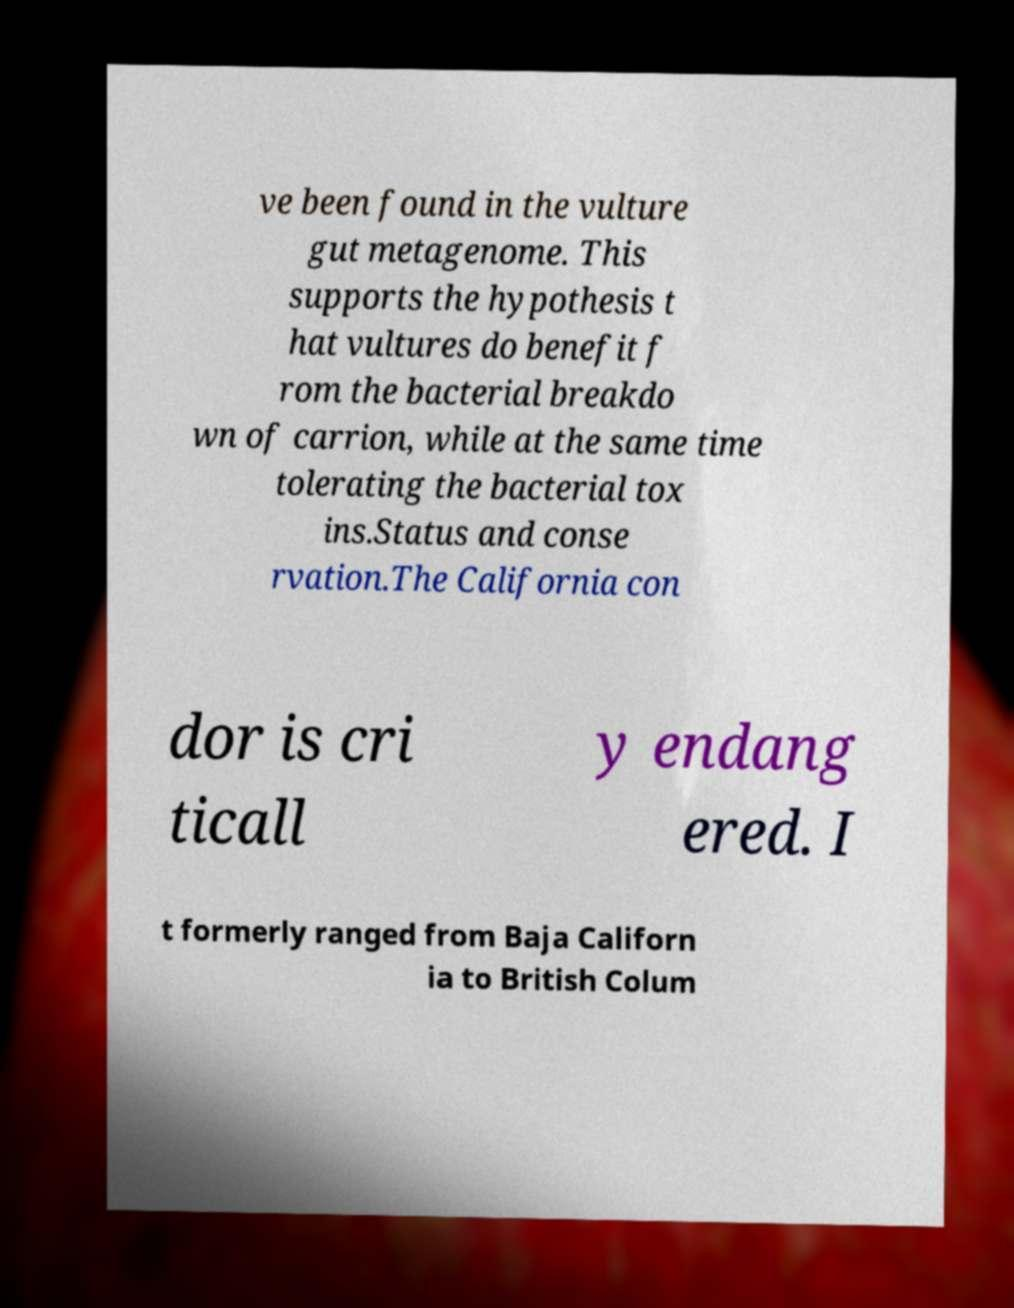What messages or text are displayed in this image? I need them in a readable, typed format. ve been found in the vulture gut metagenome. This supports the hypothesis t hat vultures do benefit f rom the bacterial breakdo wn of carrion, while at the same time tolerating the bacterial tox ins.Status and conse rvation.The California con dor is cri ticall y endang ered. I t formerly ranged from Baja Californ ia to British Colum 